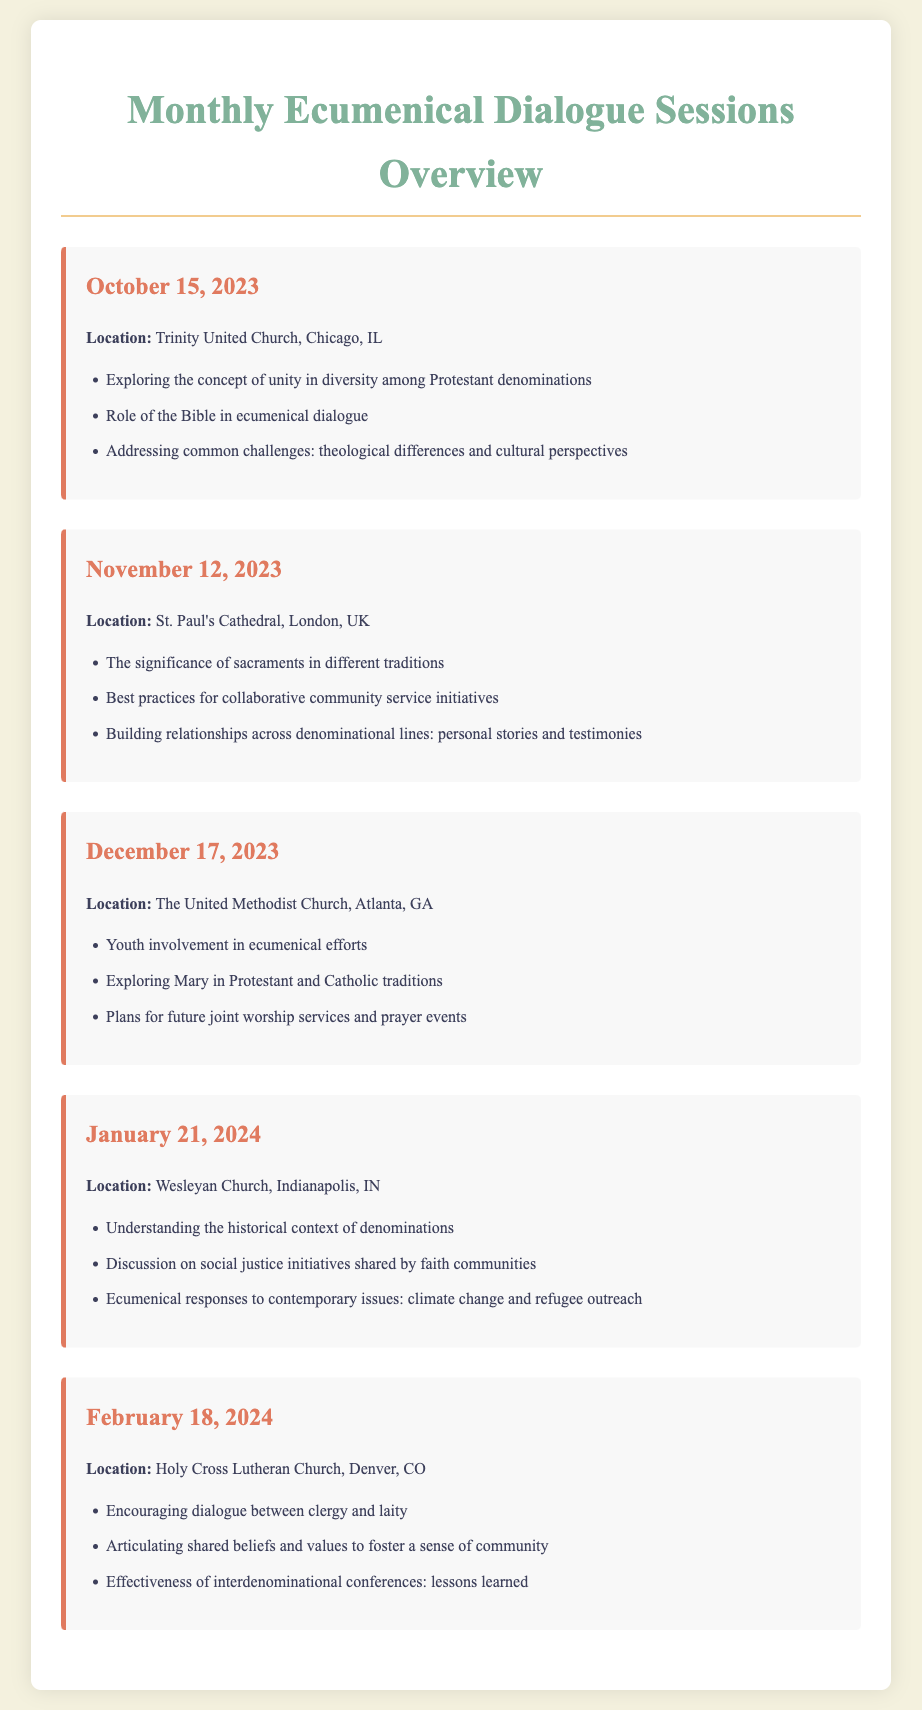What is the date of the October session? The date of the October session is mentioned directly in the title of the session section.
Answer: October 15, 2023 Where is the November session held? The location of the November session is specified right after the date in the session details.
Answer: St. Paul's Cathedral, London, UK What is one key point discussed in December? The key points are listed under each session, and one can be selected from the December session.
Answer: Youth involvement in ecumenical efforts How many sessions are scheduled for 2024? The document lists the sessions and their dates, allowing for a quick count of the sessions in 2024.
Answer: 1 What is the focus of the January session? The topics listed for the January session cover its main focus areas.
Answer: Understanding the historical context of denominations Which church is hosting the February session? The hosting church is mentioned in the details of the February session section.
Answer: Holy Cross Lutheran Church How many key discussion points are there in the November session? The number of discussion points is counted under the November session section.
Answer: 3 What common theme is found in the sessions? The sessions often explore similar topics such as unity, dialogue, and community service, indicating a recurring theme in their discussions.
Answer: Unity in diversity What type of initiatives are discussed in January? The January session discusses a specific type of initiative according to the listed points.
Answer: Social justice initiatives 